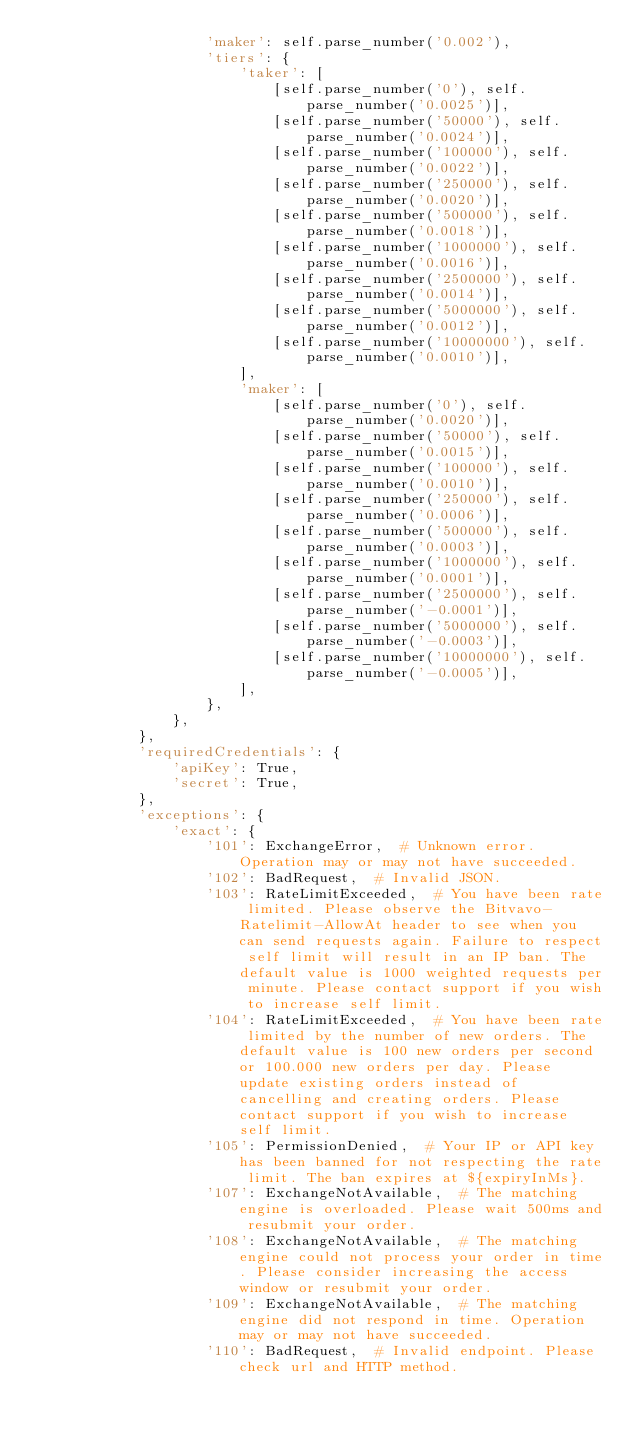<code> <loc_0><loc_0><loc_500><loc_500><_Python_>                    'maker': self.parse_number('0.002'),
                    'tiers': {
                        'taker': [
                            [self.parse_number('0'), self.parse_number('0.0025')],
                            [self.parse_number('50000'), self.parse_number('0.0024')],
                            [self.parse_number('100000'), self.parse_number('0.0022')],
                            [self.parse_number('250000'), self.parse_number('0.0020')],
                            [self.parse_number('500000'), self.parse_number('0.0018')],
                            [self.parse_number('1000000'), self.parse_number('0.0016')],
                            [self.parse_number('2500000'), self.parse_number('0.0014')],
                            [self.parse_number('5000000'), self.parse_number('0.0012')],
                            [self.parse_number('10000000'), self.parse_number('0.0010')],
                        ],
                        'maker': [
                            [self.parse_number('0'), self.parse_number('0.0020')],
                            [self.parse_number('50000'), self.parse_number('0.0015')],
                            [self.parse_number('100000'), self.parse_number('0.0010')],
                            [self.parse_number('250000'), self.parse_number('0.0006')],
                            [self.parse_number('500000'), self.parse_number('0.0003')],
                            [self.parse_number('1000000'), self.parse_number('0.0001')],
                            [self.parse_number('2500000'), self.parse_number('-0.0001')],
                            [self.parse_number('5000000'), self.parse_number('-0.0003')],
                            [self.parse_number('10000000'), self.parse_number('-0.0005')],
                        ],
                    },
                },
            },
            'requiredCredentials': {
                'apiKey': True,
                'secret': True,
            },
            'exceptions': {
                'exact': {
                    '101': ExchangeError,  # Unknown error. Operation may or may not have succeeded.
                    '102': BadRequest,  # Invalid JSON.
                    '103': RateLimitExceeded,  # You have been rate limited. Please observe the Bitvavo-Ratelimit-AllowAt header to see when you can send requests again. Failure to respect self limit will result in an IP ban. The default value is 1000 weighted requests per minute. Please contact support if you wish to increase self limit.
                    '104': RateLimitExceeded,  # You have been rate limited by the number of new orders. The default value is 100 new orders per second or 100.000 new orders per day. Please update existing orders instead of cancelling and creating orders. Please contact support if you wish to increase self limit.
                    '105': PermissionDenied,  # Your IP or API key has been banned for not respecting the rate limit. The ban expires at ${expiryInMs}.
                    '107': ExchangeNotAvailable,  # The matching engine is overloaded. Please wait 500ms and resubmit your order.
                    '108': ExchangeNotAvailable,  # The matching engine could not process your order in time. Please consider increasing the access window or resubmit your order.
                    '109': ExchangeNotAvailable,  # The matching engine did not respond in time. Operation may or may not have succeeded.
                    '110': BadRequest,  # Invalid endpoint. Please check url and HTTP method.</code> 